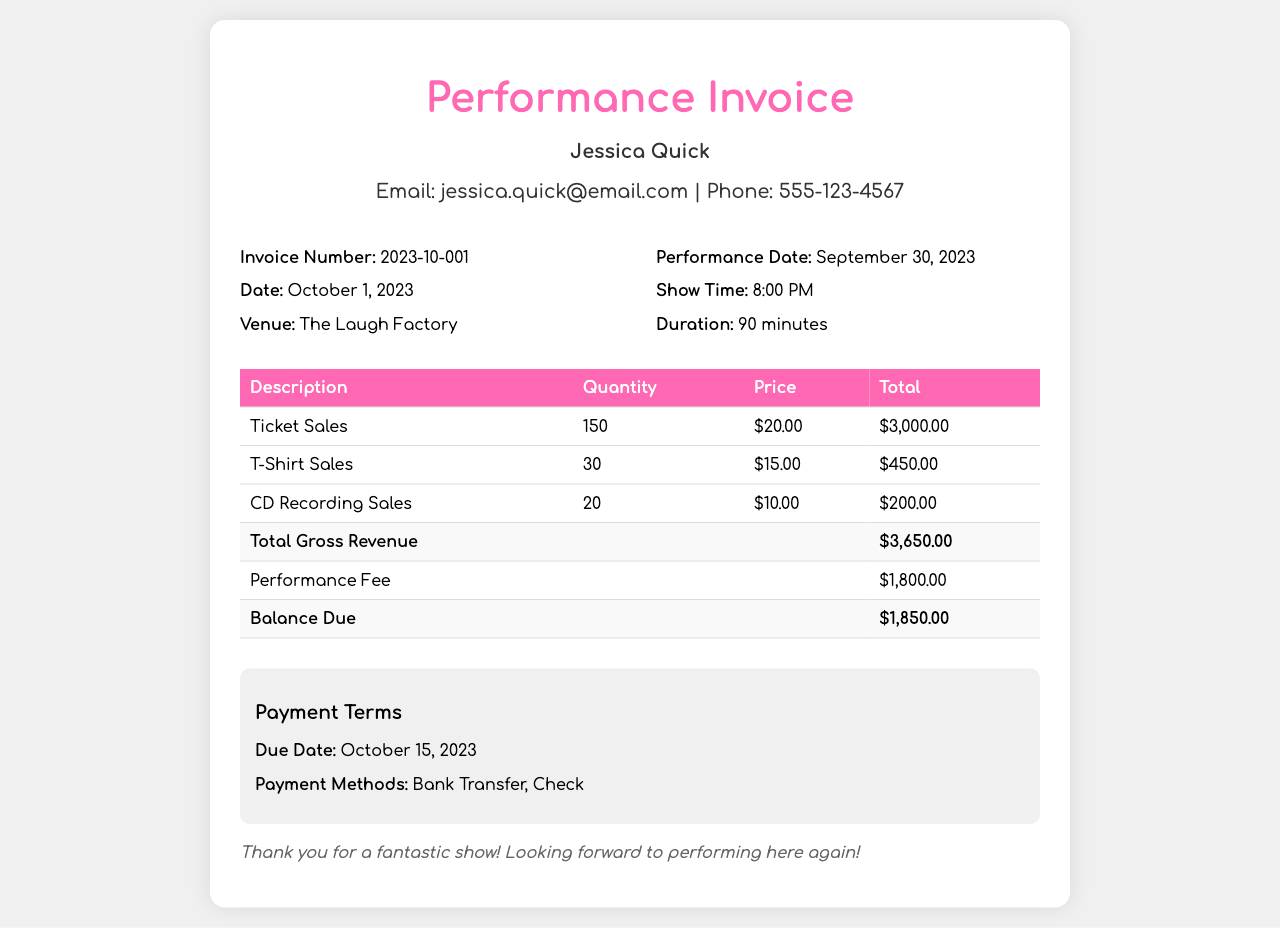What is the invoice number? The invoice number is listed in the document to uniquely identify the invoice, which is 2023-10-001.
Answer: 2023-10-001 What is the performance fee? The performance fee is stated in the document under the total fees, which is $1,800.00.
Answer: $1,800.00 How many tickets were sold? The number of tickets sold is detailed in the table under ticket sales, which is 150.
Answer: 150 What is the total gross revenue? The total gross revenue is calculated based on the ticket and merchandise sales, which amounts to $3,650.00.
Answer: $3,650.00 When is the payment due? The due date for the payment is specified in the payment terms section, which is October 15, 2023.
Answer: October 15, 2023 Which venue hosted the performance? The document specifies the venue where the performance took place, which is The Laugh Factory.
Answer: The Laugh Factory How many T-Shirts were sold? The quantity of T-Shirts sold is mentioned in the merchandise sales section, which is 30.
Answer: 30 What is the balance due? The balance due after the performance fee is stated in the invoice, which is $1,850.00.
Answer: $1,850.00 What were the showtime details? The performance showtime is listed in the document, specifying the time of the show, which is 8:00 PM.
Answer: 8:00 PM 